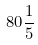Convert formula to latex. <formula><loc_0><loc_0><loc_500><loc_500>8 0 \frac { 1 } { 5 }</formula> 